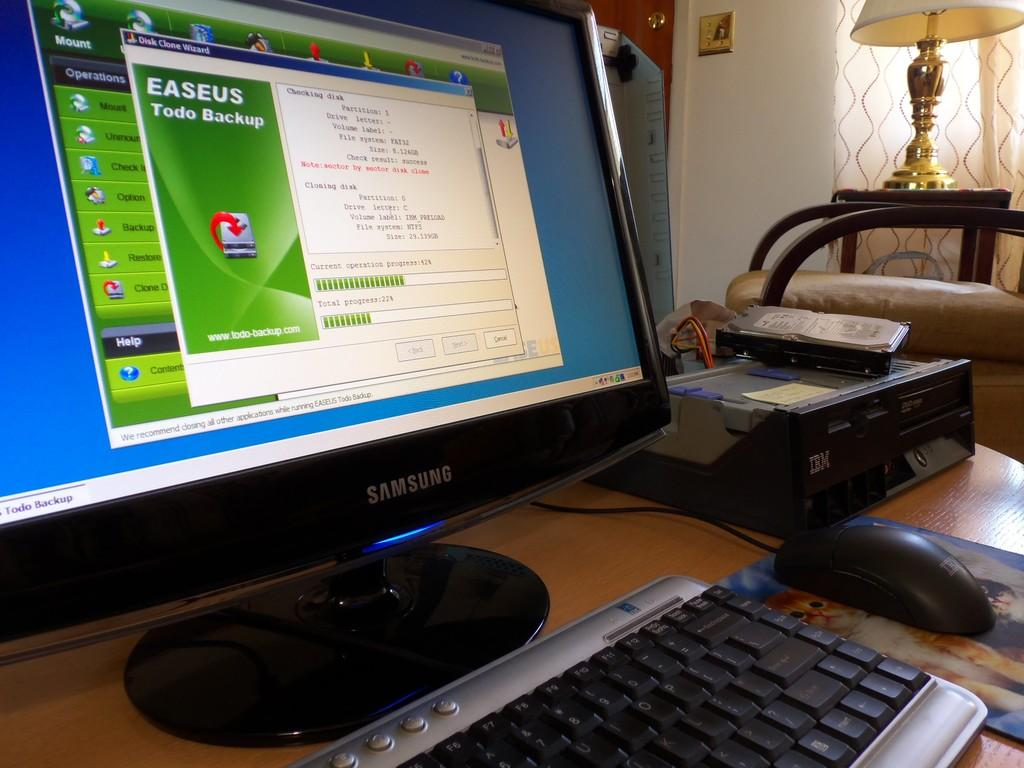Provide a one-sentence caption for the provided image. A computer that is samsung brand with easeus pulled up on the screen. 